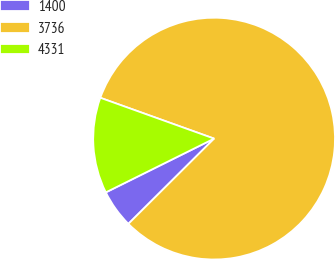Convert chart. <chart><loc_0><loc_0><loc_500><loc_500><pie_chart><fcel>1400<fcel>3736<fcel>4331<nl><fcel>5.12%<fcel>82.06%<fcel>12.82%<nl></chart> 